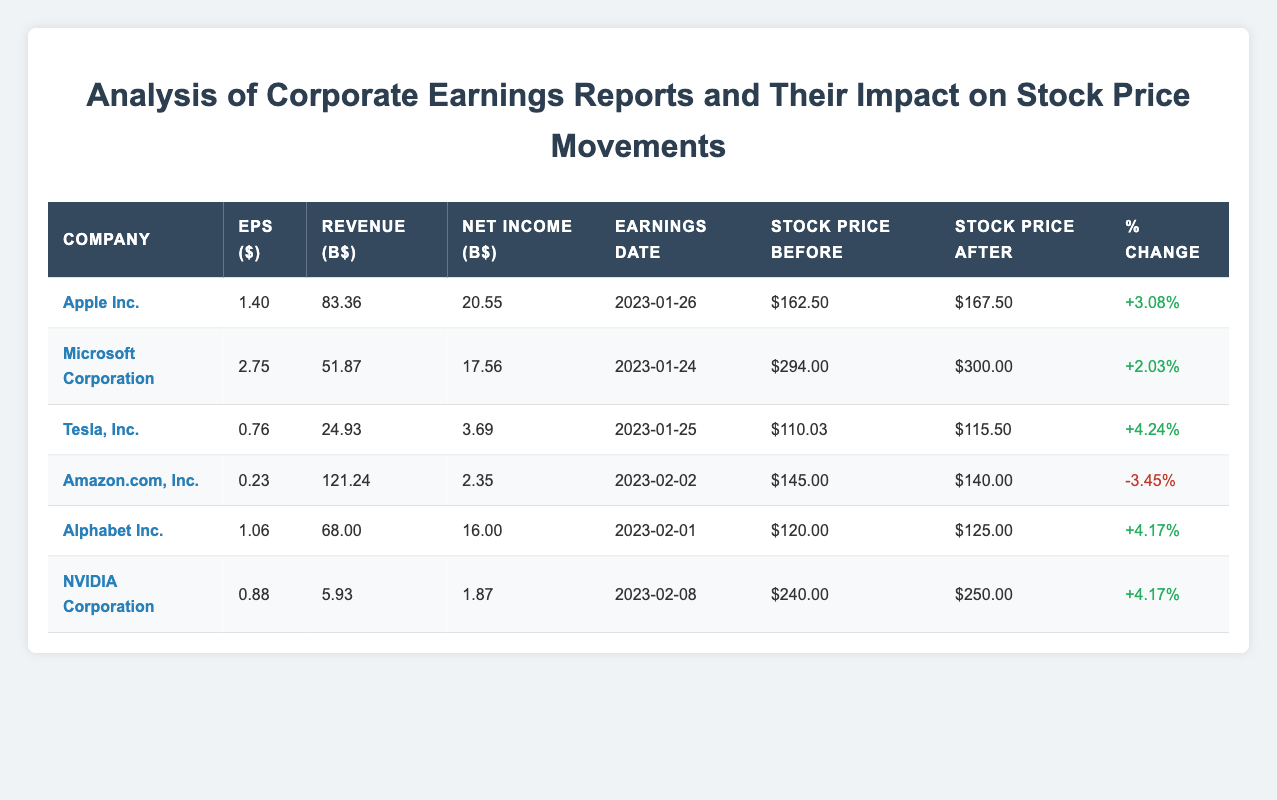What is the earnings per share for Apple Inc.? The earnings per share for Apple Inc. is displayed directly in the corresponding row under the "EPS ($)" column. It shows a value of 1.40.
Answer: 1.40 Which company experienced a negative percentage change in stock price after earnings? By reviewing the "Percentage Change" column, we see that Amazon.com, Inc. has a percentage change of -3.45%, indicating a decrease in stock price after earnings.
Answer: Amazon.com, Inc What was the stock price before earnings for Microsoft Corporation? The stock price before earnings for Microsoft Corporation is listed under the "Stock Price Before" column. It shows a value of $294.00.
Answer: $294.00 Which company had the highest stock price after earnings and what was that price? To determine which company had the highest stock price after earnings, I need to look at the "Stock Price After" column. The maximum value listed is $300.00 for Microsoft Corporation.
Answer: $300.00 What is the average percentage change in stock price for all companies listed? To find the average percentage change, we first add the percentage changes: (3.08 + 2.03 + 4.24 - 3.45 + 4.17 + 4.17) = 10.24. Then we divide by the total number of companies (6), resulting in an average of 10.24 / 6 = 1.71.
Answer: 1.71 Does Tesla, Inc. have a higher net income than Amazon.com, Inc.? Comparing the "Net Income" values, Tesla, Inc. has a net income of 3.69, while Amazon.com, Inc. has a net income of 2.35. Since 3.69 is greater than 2.35, the statement is true.
Answer: Yes What is the difference in stock price before earnings between NVIDIA Corporation and Amazon.com, Inc.? The stock price before earnings is $240.00 for NVIDIA Corporation and $145.00 for Amazon.com, Inc. The difference is calculated as $240.00 - $145.00 = $95.00.
Answer: $95.00 How many companies reported earnings per share above 1.00? By inspecting the "EPS ($)" column, we can identify that Apple Inc. (1.40), Microsoft Corporation (2.75), and Alphabet Inc. (1.06) are the companies with EPS above 1.00. This means 3 companies meet the criteria.
Answer: 3 Which company had the lowest revenue, and what was the revenue amount? The "Revenue (B$)" column indicates values for all companies. The lowest value is 5.93 for NVIDIA Corporation.
Answer: NVIDIA Corporation, 5.93 B$ 